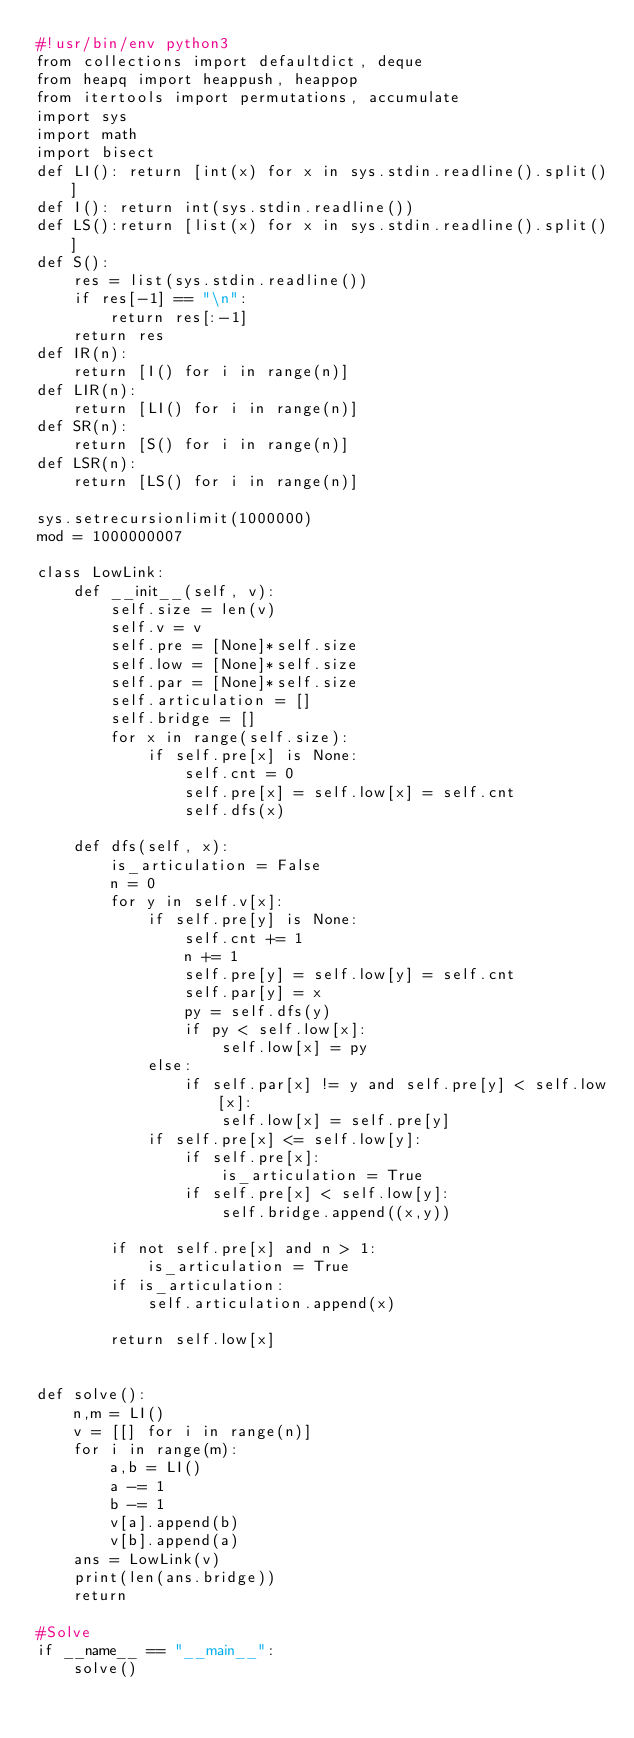Convert code to text. <code><loc_0><loc_0><loc_500><loc_500><_Python_>#!usr/bin/env python3
from collections import defaultdict, deque
from heapq import heappush, heappop
from itertools import permutations, accumulate
import sys
import math
import bisect
def LI(): return [int(x) for x in sys.stdin.readline().split()]
def I(): return int(sys.stdin.readline())
def LS():return [list(x) for x in sys.stdin.readline().split()]
def S():
    res = list(sys.stdin.readline())
    if res[-1] == "\n":
        return res[:-1]
    return res
def IR(n):
    return [I() for i in range(n)]
def LIR(n):
    return [LI() for i in range(n)]
def SR(n):
    return [S() for i in range(n)]
def LSR(n):
    return [LS() for i in range(n)]

sys.setrecursionlimit(1000000)
mod = 1000000007

class LowLink:
    def __init__(self, v):
        self.size = len(v)
        self.v = v
        self.pre = [None]*self.size
        self.low = [None]*self.size
        self.par = [None]*self.size
        self.articulation = []
        self.bridge = []
        for x in range(self.size):
            if self.pre[x] is None:
                self.cnt = 0
                self.pre[x] = self.low[x] = self.cnt
                self.dfs(x)

    def dfs(self, x):
        is_articulation = False
        n = 0
        for y in self.v[x]:
            if self.pre[y] is None:
                self.cnt += 1
                n += 1
                self.pre[y] = self.low[y] = self.cnt
                self.par[y] = x
                py = self.dfs(y)
                if py < self.low[x]:
                    self.low[x] = py
            else:
                if self.par[x] != y and self.pre[y] < self.low[x]:
                    self.low[x] = self.pre[y]
            if self.pre[x] <= self.low[y]:
                if self.pre[x]:
                    is_articulation = True
                if self.pre[x] < self.low[y]:
                    self.bridge.append((x,y))

        if not self.pre[x] and n > 1:
            is_articulation = True
        if is_articulation:
            self.articulation.append(x)

        return self.low[x]


def solve():
    n,m = LI()
    v = [[] for i in range(n)]
    for i in range(m):
        a,b = LI()
        a -= 1
        b -= 1
        v[a].append(b)
        v[b].append(a)
    ans = LowLink(v)
    print(len(ans.bridge))
    return

#Solve
if __name__ == "__main__":
    solve()
</code> 